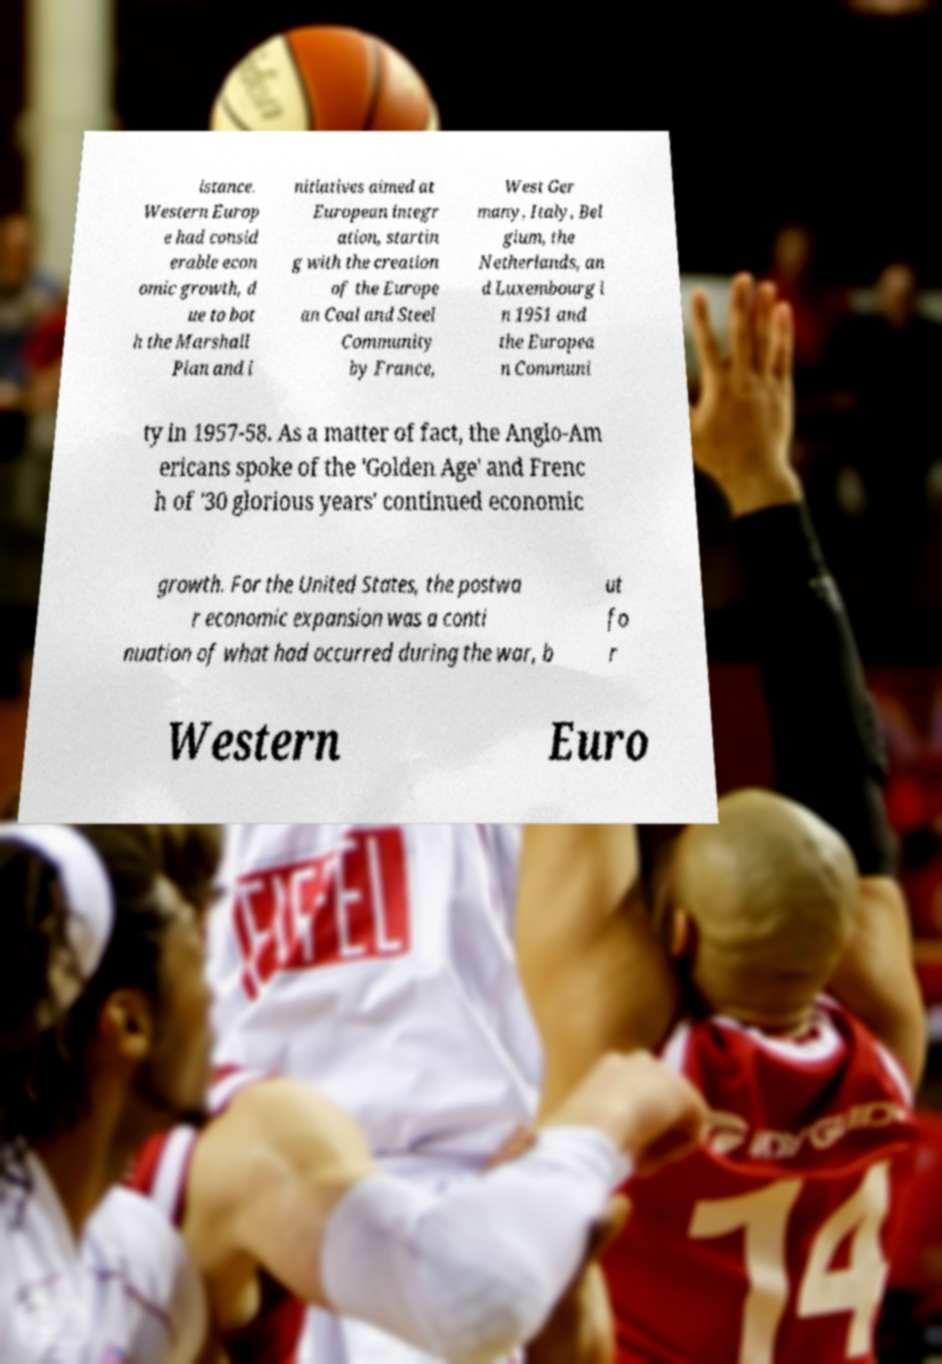Could you assist in decoding the text presented in this image and type it out clearly? istance. Western Europ e had consid erable econ omic growth, d ue to bot h the Marshall Plan and i nitiatives aimed at European integr ation, startin g with the creation of the Europe an Coal and Steel Community by France, West Ger many, Italy, Bel gium, the Netherlands, an d Luxembourg i n 1951 and the Europea n Communi ty in 1957-58. As a matter of fact, the Anglo-Am ericans spoke of the 'Golden Age' and Frenc h of '30 glorious years' continued economic growth. For the United States, the postwa r economic expansion was a conti nuation of what had occurred during the war, b ut fo r Western Euro 